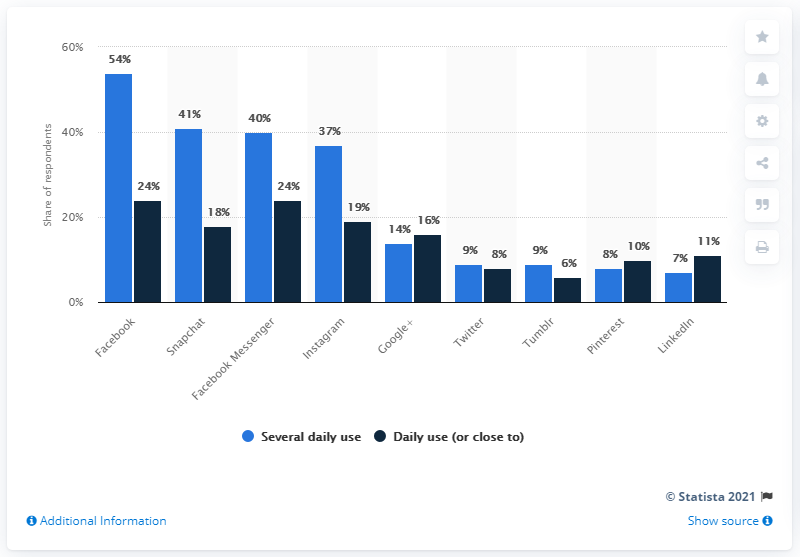Point out several critical features in this image. The daily use of the service decreases as time increases. According to data from 2018, the most popular social media platform among daily social media users in Denmark was Facebook. According to data from 2018, Snapchat was the most popular social media platform in Denmark. The difference between the highest and lowest daily use values is 47. 